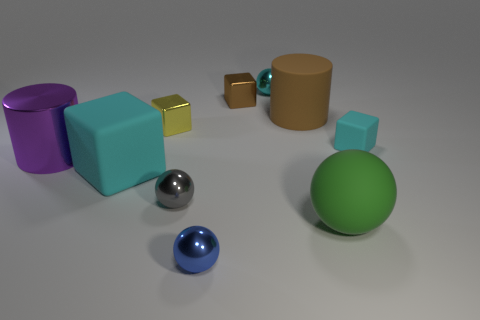Subtract all red cylinders. How many cyan blocks are left? 2 Subtract all large matte balls. How many balls are left? 3 Subtract 1 balls. How many balls are left? 3 Subtract all yellow cubes. How many cubes are left? 3 Subtract all purple blocks. Subtract all yellow balls. How many blocks are left? 4 Subtract all balls. How many objects are left? 6 Subtract 1 purple cylinders. How many objects are left? 9 Subtract all big balls. Subtract all tiny cyan metallic things. How many objects are left? 8 Add 5 big purple cylinders. How many big purple cylinders are left? 6 Add 6 tiny cyan metal balls. How many tiny cyan metal balls exist? 7 